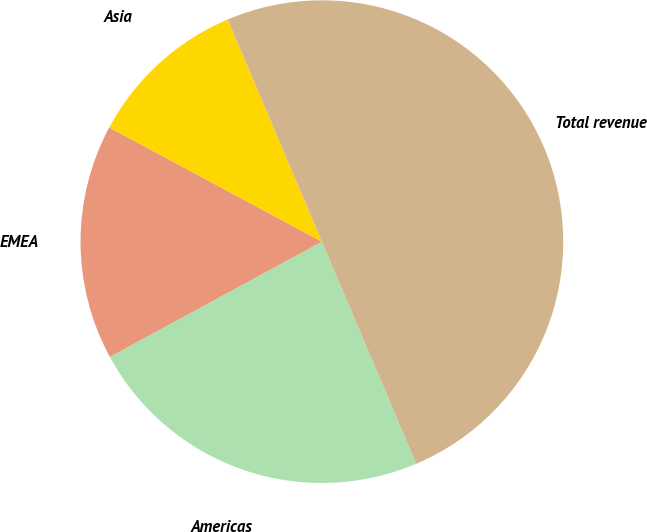<chart> <loc_0><loc_0><loc_500><loc_500><pie_chart><fcel>Americas<fcel>EMEA<fcel>Asia<fcel>Total revenue<nl><fcel>23.47%<fcel>15.77%<fcel>10.77%<fcel>50.0%<nl></chart> 